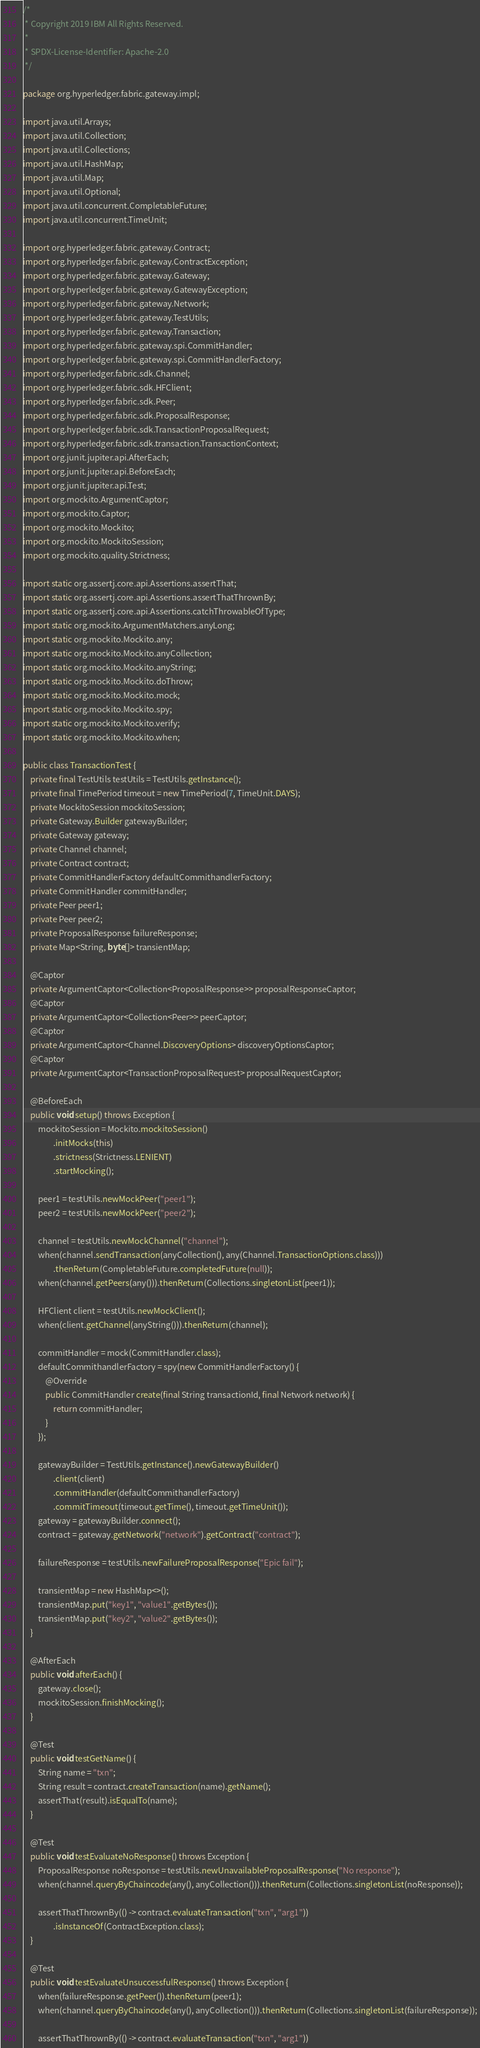<code> <loc_0><loc_0><loc_500><loc_500><_Java_>/*
 * Copyright 2019 IBM All Rights Reserved.
 *
 * SPDX-License-Identifier: Apache-2.0
 */

package org.hyperledger.fabric.gateway.impl;

import java.util.Arrays;
import java.util.Collection;
import java.util.Collections;
import java.util.HashMap;
import java.util.Map;
import java.util.Optional;
import java.util.concurrent.CompletableFuture;
import java.util.concurrent.TimeUnit;

import org.hyperledger.fabric.gateway.Contract;
import org.hyperledger.fabric.gateway.ContractException;
import org.hyperledger.fabric.gateway.Gateway;
import org.hyperledger.fabric.gateway.GatewayException;
import org.hyperledger.fabric.gateway.Network;
import org.hyperledger.fabric.gateway.TestUtils;
import org.hyperledger.fabric.gateway.Transaction;
import org.hyperledger.fabric.gateway.spi.CommitHandler;
import org.hyperledger.fabric.gateway.spi.CommitHandlerFactory;
import org.hyperledger.fabric.sdk.Channel;
import org.hyperledger.fabric.sdk.HFClient;
import org.hyperledger.fabric.sdk.Peer;
import org.hyperledger.fabric.sdk.ProposalResponse;
import org.hyperledger.fabric.sdk.TransactionProposalRequest;
import org.hyperledger.fabric.sdk.transaction.TransactionContext;
import org.junit.jupiter.api.AfterEach;
import org.junit.jupiter.api.BeforeEach;
import org.junit.jupiter.api.Test;
import org.mockito.ArgumentCaptor;
import org.mockito.Captor;
import org.mockito.Mockito;
import org.mockito.MockitoSession;
import org.mockito.quality.Strictness;

import static org.assertj.core.api.Assertions.assertThat;
import static org.assertj.core.api.Assertions.assertThatThrownBy;
import static org.assertj.core.api.Assertions.catchThrowableOfType;
import static org.mockito.ArgumentMatchers.anyLong;
import static org.mockito.Mockito.any;
import static org.mockito.Mockito.anyCollection;
import static org.mockito.Mockito.anyString;
import static org.mockito.Mockito.doThrow;
import static org.mockito.Mockito.mock;
import static org.mockito.Mockito.spy;
import static org.mockito.Mockito.verify;
import static org.mockito.Mockito.when;

public class TransactionTest {
    private final TestUtils testUtils = TestUtils.getInstance();
    private final TimePeriod timeout = new TimePeriod(7, TimeUnit.DAYS);
    private MockitoSession mockitoSession;
    private Gateway.Builder gatewayBuilder;
    private Gateway gateway;
    private Channel channel;
    private Contract contract;
    private CommitHandlerFactory defaultCommithandlerFactory;
    private CommitHandler commitHandler;
    private Peer peer1;
    private Peer peer2;
    private ProposalResponse failureResponse;
    private Map<String, byte[]> transientMap;

    @Captor
    private ArgumentCaptor<Collection<ProposalResponse>> proposalResponseCaptor;
    @Captor
    private ArgumentCaptor<Collection<Peer>> peerCaptor;
    @Captor
    private ArgumentCaptor<Channel.DiscoveryOptions> discoveryOptionsCaptor;
    @Captor
    private ArgumentCaptor<TransactionProposalRequest> proposalRequestCaptor;

    @BeforeEach
    public void setup() throws Exception {
        mockitoSession = Mockito.mockitoSession()
                .initMocks(this)
                .strictness(Strictness.LENIENT)
                .startMocking();

        peer1 = testUtils.newMockPeer("peer1");
        peer2 = testUtils.newMockPeer("peer2");

        channel = testUtils.newMockChannel("channel");
        when(channel.sendTransaction(anyCollection(), any(Channel.TransactionOptions.class)))
                .thenReturn(CompletableFuture.completedFuture(null));
        when(channel.getPeers(any())).thenReturn(Collections.singletonList(peer1));

        HFClient client = testUtils.newMockClient();
        when(client.getChannel(anyString())).thenReturn(channel);

        commitHandler = mock(CommitHandler.class);
        defaultCommithandlerFactory = spy(new CommitHandlerFactory() {
            @Override
            public CommitHandler create(final String transactionId, final Network network) {
                return commitHandler;
            }
        });

        gatewayBuilder = TestUtils.getInstance().newGatewayBuilder()
                .client(client)
                .commitHandler(defaultCommithandlerFactory)
                .commitTimeout(timeout.getTime(), timeout.getTimeUnit());
        gateway = gatewayBuilder.connect();
        contract = gateway.getNetwork("network").getContract("contract");

        failureResponse = testUtils.newFailureProposalResponse("Epic fail");

        transientMap = new HashMap<>();
    	transientMap.put("key1", "value1".getBytes());
    	transientMap.put("key2", "value2".getBytes());
    }

    @AfterEach
    public void afterEach() {
        gateway.close();
        mockitoSession.finishMocking();
    }

    @Test
    public void testGetName() {
        String name = "txn";
        String result = contract.createTransaction(name).getName();
        assertThat(result).isEqualTo(name);
    }

    @Test
    public void testEvaluateNoResponse() throws Exception {
        ProposalResponse noResponse = testUtils.newUnavailableProposalResponse("No response");
        when(channel.queryByChaincode(any(), anyCollection())).thenReturn(Collections.singletonList(noResponse));

        assertThatThrownBy(() -> contract.evaluateTransaction("txn", "arg1"))
                .isInstanceOf(ContractException.class);
    }

    @Test
    public void testEvaluateUnsuccessfulResponse() throws Exception {
        when(failureResponse.getPeer()).thenReturn(peer1);
        when(channel.queryByChaincode(any(), anyCollection())).thenReturn(Collections.singletonList(failureResponse));

        assertThatThrownBy(() -> contract.evaluateTransaction("txn", "arg1"))</code> 